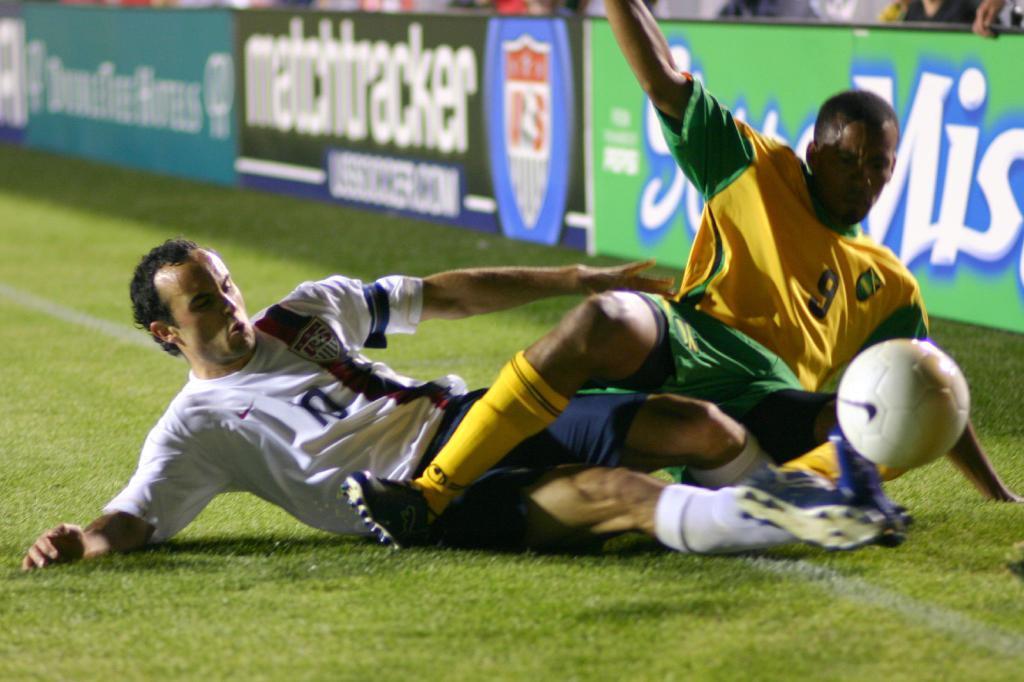Please provide a concise description of this image. There are two players in a football match. They are trying to kick the football. One is totally in slipped position and the other is trying to jump above him. They crossed the line. There are few boards beside them. 